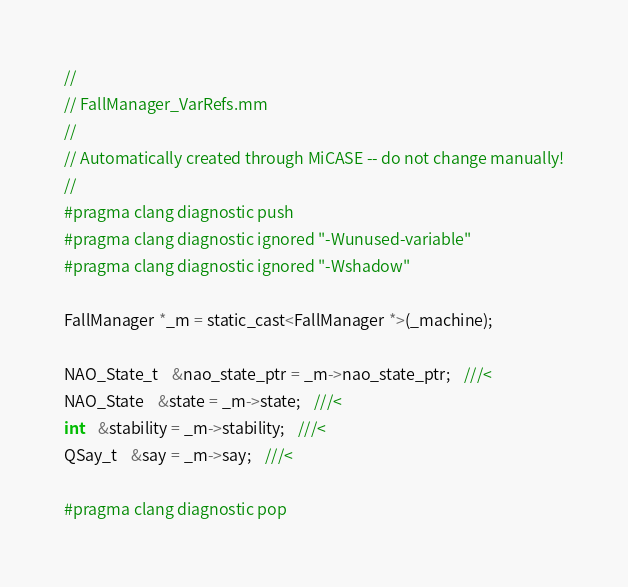<code> <loc_0><loc_0><loc_500><loc_500><_ObjectiveC_>//
// FallManager_VarRefs.mm
//
// Automatically created through MiCASE -- do not change manually!
//
#pragma clang diagnostic push
#pragma clang diagnostic ignored "-Wunused-variable"
#pragma clang diagnostic ignored "-Wshadow"

FallManager *_m = static_cast<FallManager *>(_machine);

NAO_State_t	&nao_state_ptr = _m->nao_state_ptr;	///< 
NAO_State	&state = _m->state;	///< 
int	&stability = _m->stability;	///< 
QSay_t	&say = _m->say;	///< 

#pragma clang diagnostic pop
</code> 